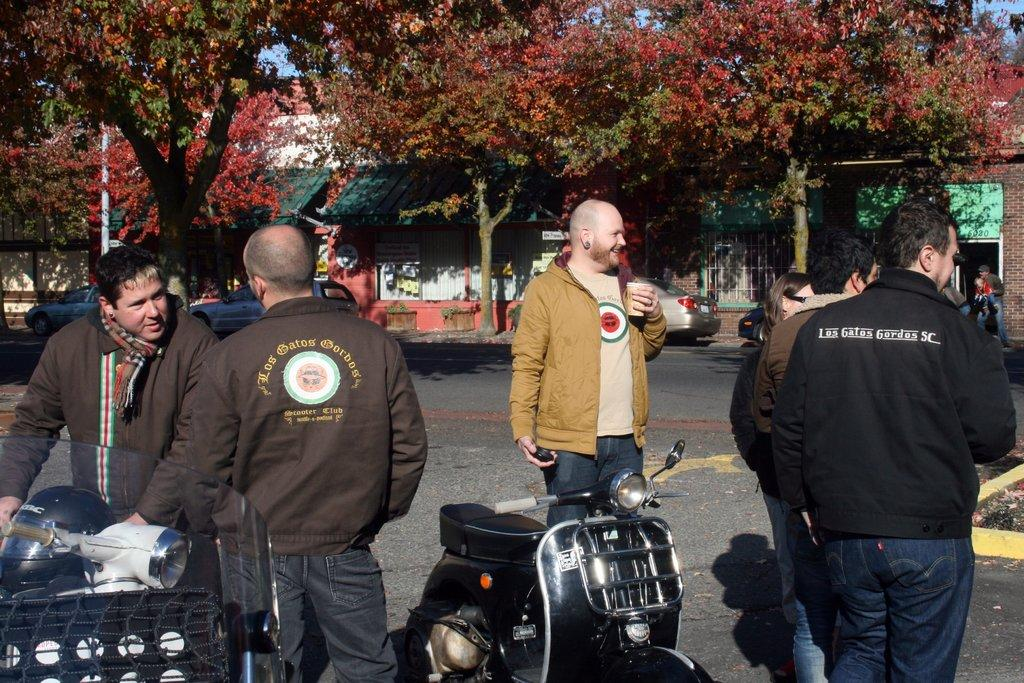What are the men in the image wearing? The men in the image are wearing jackets. Where are the men standing in the image? The men are standing on a road in the image. What vehicles can be seen in the front of the image? There are two scooters in the front of the image. What is visible in the background of the image? There are trees in the background of the image, and they are in front of a building. What else can be seen in front of the building? There are cars in front of the building. Can you see any wings on the scooters in the image? There are no wings visible on the scooters in the image. What type of linen is draped over the trees in the background? There is no linen draped over the trees in the background; the trees are simply standing in front of a building. 